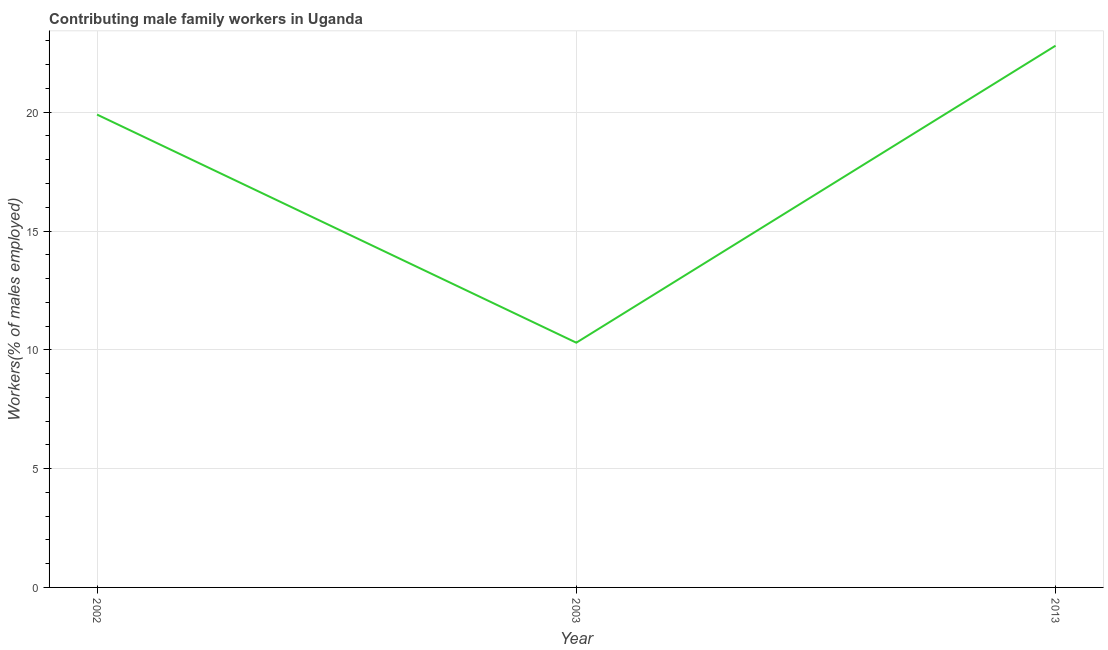What is the contributing male family workers in 2002?
Offer a very short reply. 19.9. Across all years, what is the maximum contributing male family workers?
Provide a succinct answer. 22.8. Across all years, what is the minimum contributing male family workers?
Your response must be concise. 10.3. In which year was the contributing male family workers minimum?
Keep it short and to the point. 2003. What is the sum of the contributing male family workers?
Provide a short and direct response. 53. What is the difference between the contributing male family workers in 2002 and 2013?
Your response must be concise. -2.9. What is the average contributing male family workers per year?
Ensure brevity in your answer.  17.67. What is the median contributing male family workers?
Keep it short and to the point. 19.9. In how many years, is the contributing male family workers greater than 20 %?
Give a very brief answer. 1. Do a majority of the years between 2013 and 2003 (inclusive) have contributing male family workers greater than 7 %?
Offer a very short reply. No. What is the ratio of the contributing male family workers in 2002 to that in 2013?
Keep it short and to the point. 0.87. What is the difference between the highest and the second highest contributing male family workers?
Your response must be concise. 2.9. What is the difference between the highest and the lowest contributing male family workers?
Provide a succinct answer. 12.5. Does the contributing male family workers monotonically increase over the years?
Your answer should be very brief. No. How many lines are there?
Make the answer very short. 1. What is the difference between two consecutive major ticks on the Y-axis?
Provide a short and direct response. 5. Does the graph contain any zero values?
Your answer should be very brief. No. What is the title of the graph?
Keep it short and to the point. Contributing male family workers in Uganda. What is the label or title of the X-axis?
Offer a terse response. Year. What is the label or title of the Y-axis?
Give a very brief answer. Workers(% of males employed). What is the Workers(% of males employed) of 2002?
Provide a short and direct response. 19.9. What is the Workers(% of males employed) in 2003?
Make the answer very short. 10.3. What is the Workers(% of males employed) of 2013?
Offer a terse response. 22.8. What is the difference between the Workers(% of males employed) in 2003 and 2013?
Ensure brevity in your answer.  -12.5. What is the ratio of the Workers(% of males employed) in 2002 to that in 2003?
Provide a succinct answer. 1.93. What is the ratio of the Workers(% of males employed) in 2002 to that in 2013?
Keep it short and to the point. 0.87. What is the ratio of the Workers(% of males employed) in 2003 to that in 2013?
Offer a terse response. 0.45. 